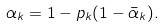Convert formula to latex. <formula><loc_0><loc_0><loc_500><loc_500>\alpha _ { k } = 1 - p _ { k } ( 1 - \bar { \alpha } _ { k } ) .</formula> 